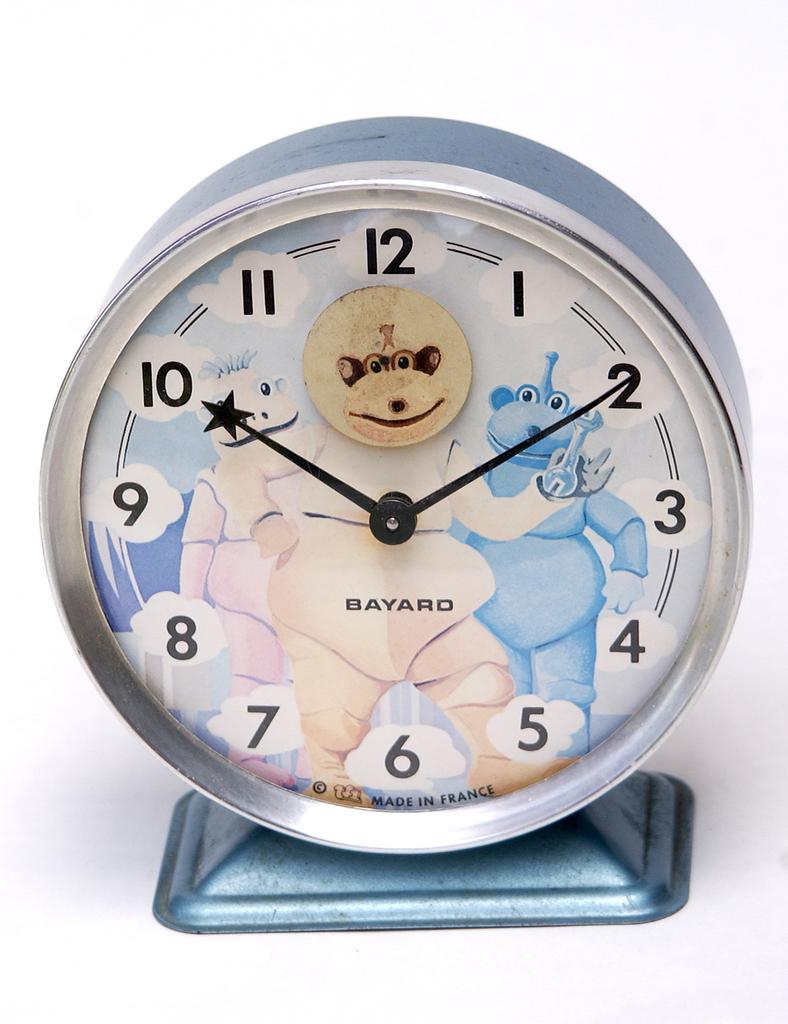<image>
Present a compact description of the photo's key features. A Bayard clock features off-brand Telletubbies on it. 